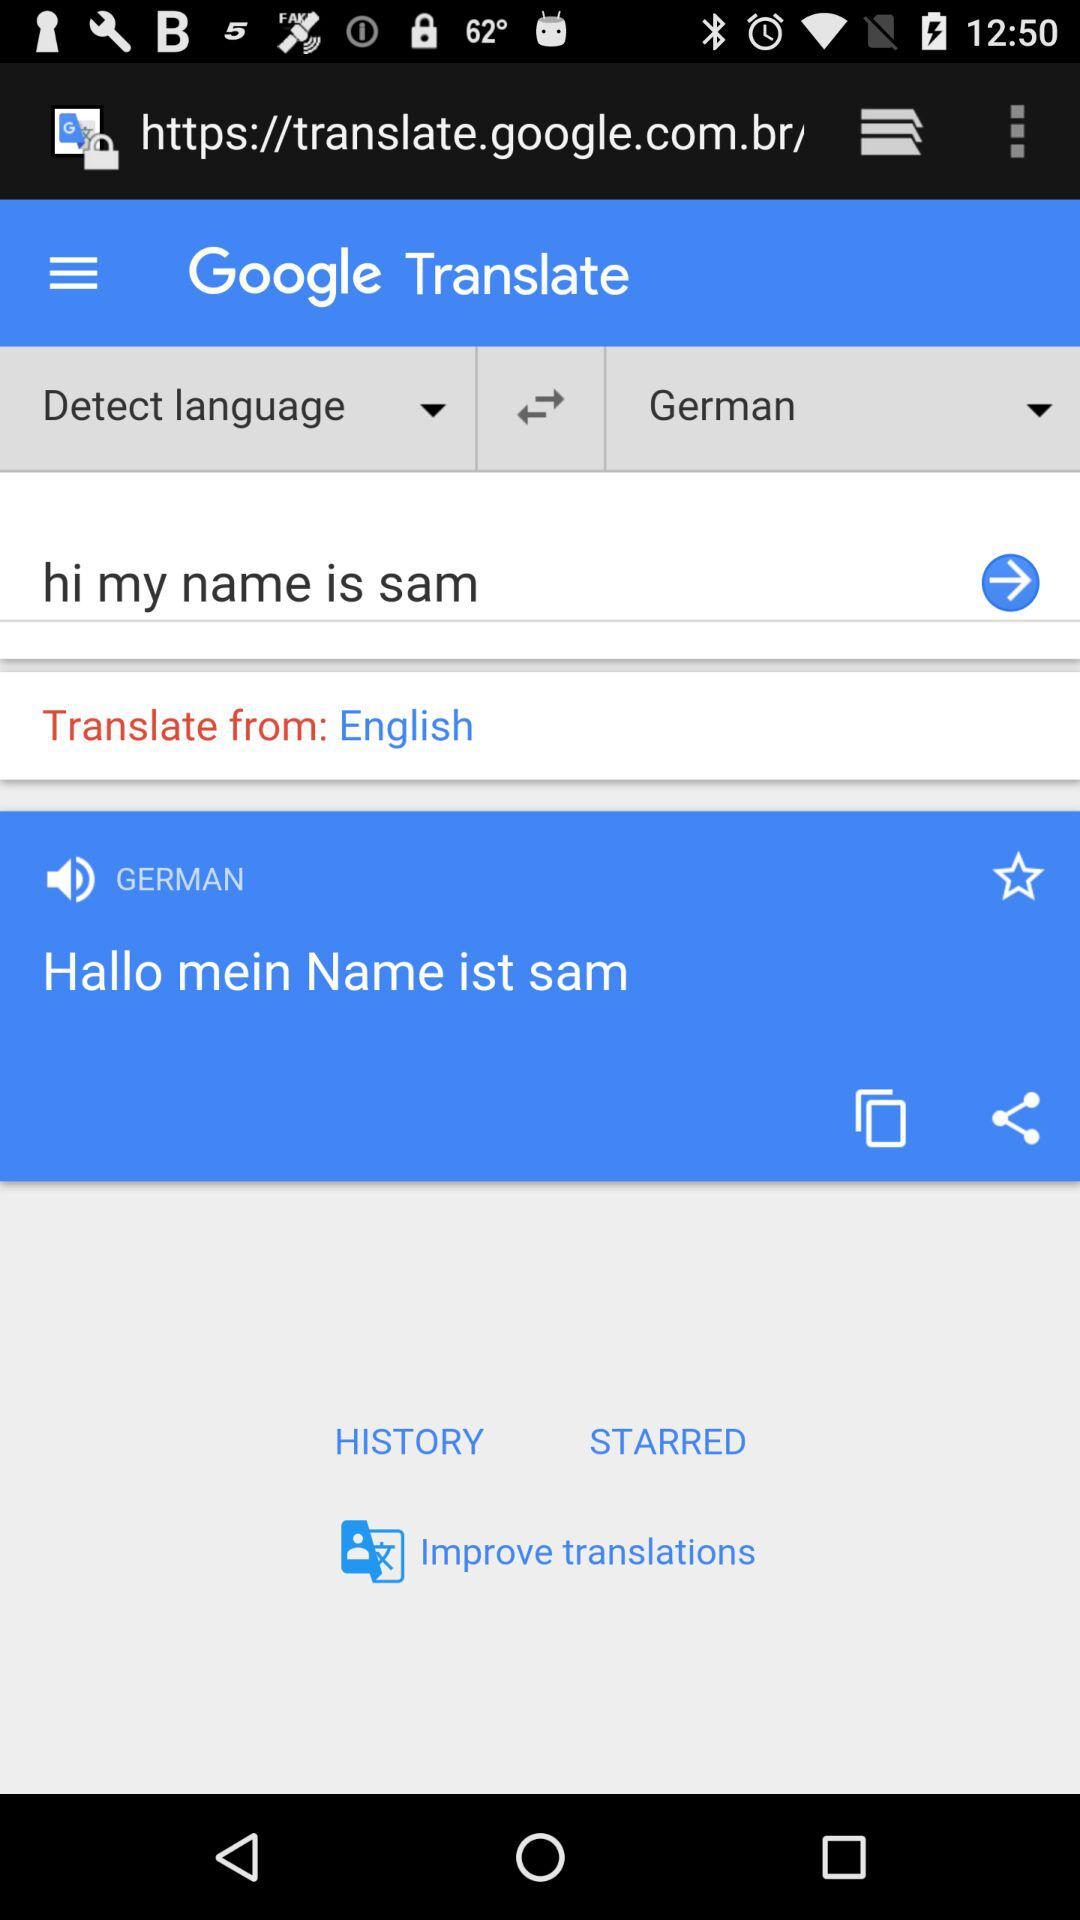What is the text entered for the translation? The entered text is "hi my name is sam". 